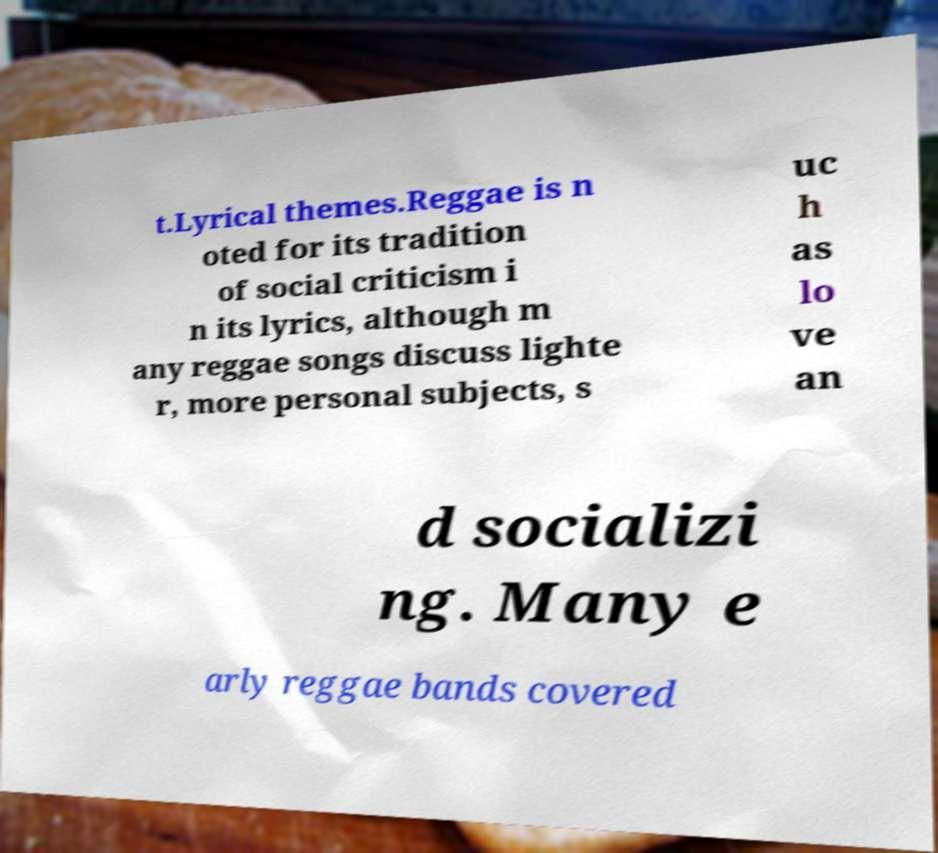I need the written content from this picture converted into text. Can you do that? t.Lyrical themes.Reggae is n oted for its tradition of social criticism i n its lyrics, although m any reggae songs discuss lighte r, more personal subjects, s uc h as lo ve an d socializi ng. Many e arly reggae bands covered 